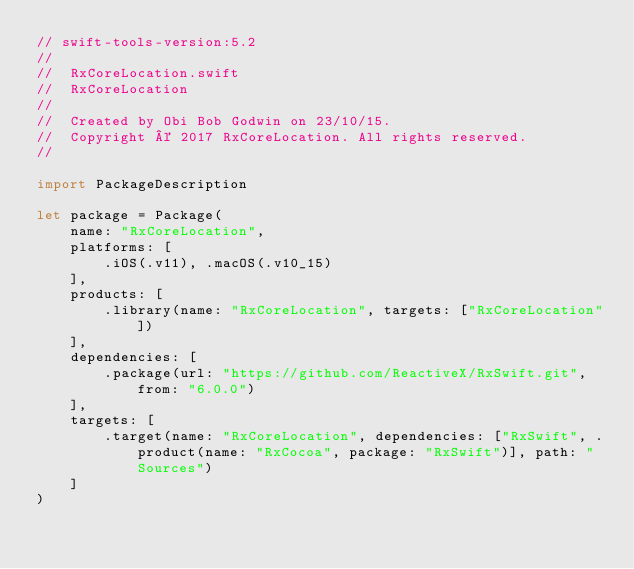Convert code to text. <code><loc_0><loc_0><loc_500><loc_500><_Swift_>// swift-tools-version:5.2
//
//  RxCoreLocation.swift
//  RxCoreLocation
//
//  Created by Obi Bob Godwin on 23/10/15.
//  Copyright © 2017 RxCoreLocation. All rights reserved.
//

import PackageDescription

let package = Package(
    name: "RxCoreLocation",
    platforms: [
        .iOS(.v11), .macOS(.v10_15)
    ],
    products: [
        .library(name: "RxCoreLocation", targets: ["RxCoreLocation"])
    ],
    dependencies: [
        .package(url: "https://github.com/ReactiveX/RxSwift.git", from: "6.0.0")
    ],
    targets: [
        .target(name: "RxCoreLocation", dependencies: ["RxSwift", .product(name: "RxCocoa", package: "RxSwift")], path: "Sources")
    ]
)
</code> 